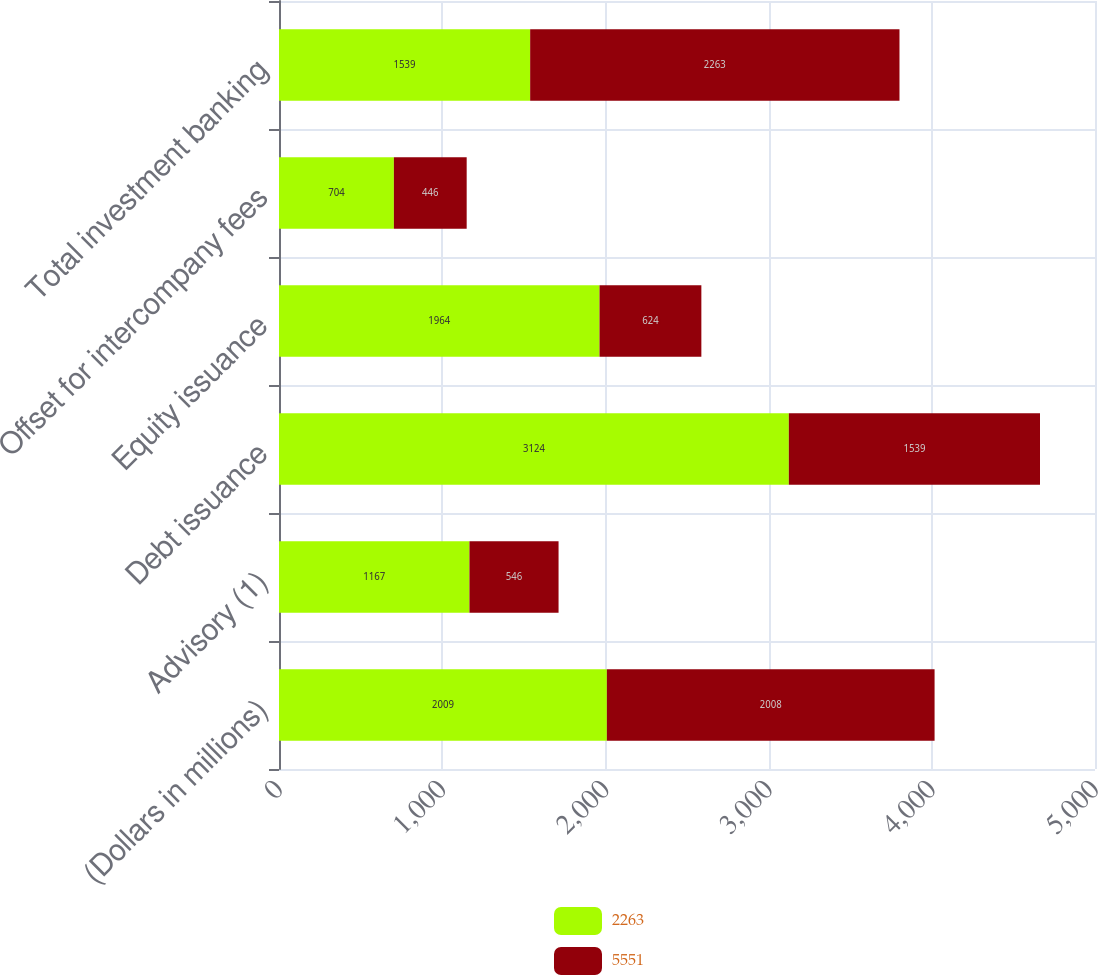Convert chart to OTSL. <chart><loc_0><loc_0><loc_500><loc_500><stacked_bar_chart><ecel><fcel>(Dollars in millions)<fcel>Advisory (1)<fcel>Debt issuance<fcel>Equity issuance<fcel>Offset for intercompany fees<fcel>Total investment banking<nl><fcel>2263<fcel>2009<fcel>1167<fcel>3124<fcel>1964<fcel>704<fcel>1539<nl><fcel>5551<fcel>2008<fcel>546<fcel>1539<fcel>624<fcel>446<fcel>2263<nl></chart> 